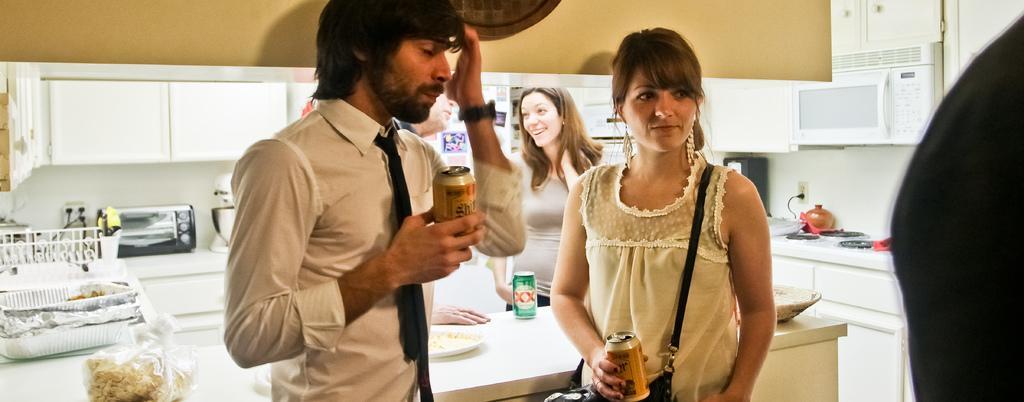Can you describe this image briefly? This is a picture of a kitchen room. In this picture we can see people. We can see a man and a woman holding drinking tins in their hands. In the background we can see cupboards in white color. On the kitchen platform we can see few objects, food and tin in green color. 